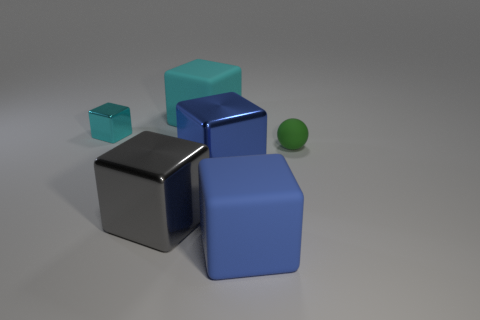Subtract 2 blocks. How many blocks are left? 3 Subtract all large shiny cubes. How many cubes are left? 3 Subtract all gray cubes. How many cubes are left? 4 Add 4 tiny red metallic cylinders. How many objects exist? 10 Subtract all yellow cubes. Subtract all purple balls. How many cubes are left? 5 Subtract all balls. How many objects are left? 5 Subtract all small cyan shiny blocks. Subtract all small gray matte things. How many objects are left? 5 Add 2 blue rubber things. How many blue rubber things are left? 3 Add 3 small purple metal cubes. How many small purple metal cubes exist? 3 Subtract 0 brown balls. How many objects are left? 6 